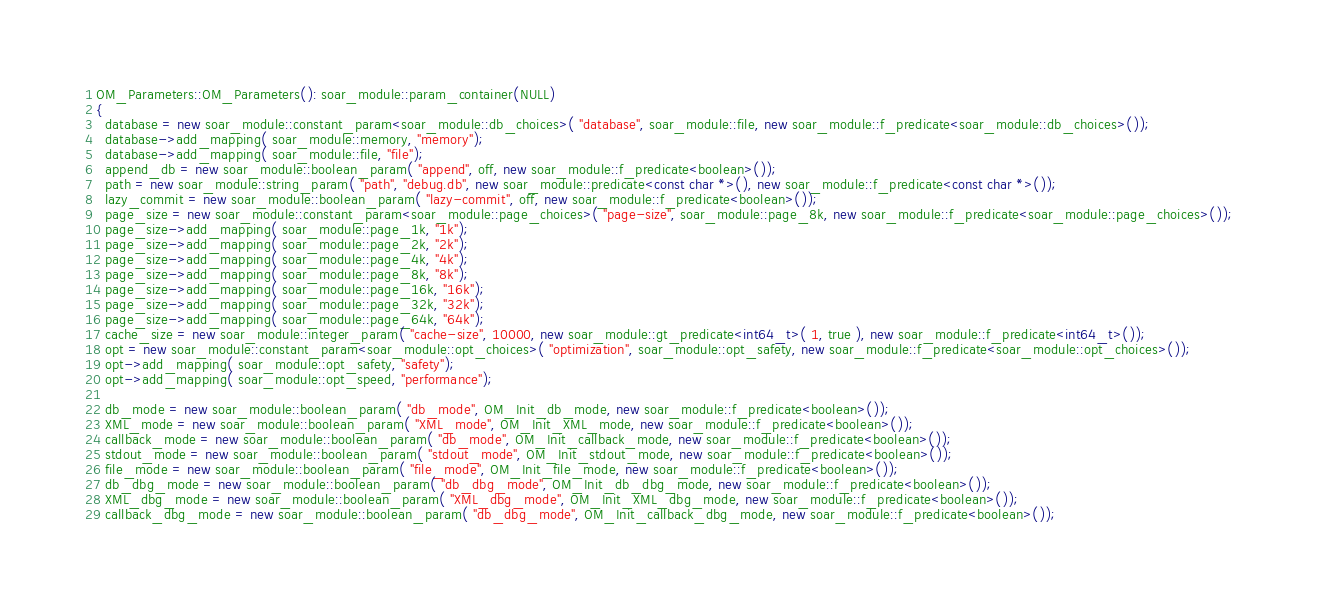Convert code to text. <code><loc_0><loc_0><loc_500><loc_500><_C++_>OM_Parameters::OM_Parameters(): soar_module::param_container(NULL)
{
  database = new soar_module::constant_param<soar_module::db_choices>( "database", soar_module::file, new soar_module::f_predicate<soar_module::db_choices>());
  database->add_mapping( soar_module::memory, "memory");
  database->add_mapping( soar_module::file, "file");
  append_db = new soar_module::boolean_param( "append", off, new soar_module::f_predicate<boolean>());
  path = new soar_module::string_param( "path", "debug.db", new soar_module::predicate<const char *>(), new soar_module::f_predicate<const char *>());
  lazy_commit = new soar_module::boolean_param( "lazy-commit", off, new soar_module::f_predicate<boolean>());
  page_size = new soar_module::constant_param<soar_module::page_choices>( "page-size", soar_module::page_8k, new soar_module::f_predicate<soar_module::page_choices>());
  page_size->add_mapping( soar_module::page_1k, "1k");
  page_size->add_mapping( soar_module::page_2k, "2k");
  page_size->add_mapping( soar_module::page_4k, "4k");
  page_size->add_mapping( soar_module::page_8k, "8k");
  page_size->add_mapping( soar_module::page_16k, "16k");
  page_size->add_mapping( soar_module::page_32k, "32k");
  page_size->add_mapping( soar_module::page_64k, "64k");
  cache_size = new soar_module::integer_param( "cache-size", 10000, new soar_module::gt_predicate<int64_t>( 1, true ), new soar_module::f_predicate<int64_t>());
  opt = new soar_module::constant_param<soar_module::opt_choices>( "optimization", soar_module::opt_safety, new soar_module::f_predicate<soar_module::opt_choices>());
  opt->add_mapping( soar_module::opt_safety, "safety");
  opt->add_mapping( soar_module::opt_speed, "performance");

  db_mode = new soar_module::boolean_param( "db_mode", OM_Init_db_mode, new soar_module::f_predicate<boolean>());
  XML_mode = new soar_module::boolean_param( "XML_mode", OM_Init_XML_mode, new soar_module::f_predicate<boolean>());
  callback_mode = new soar_module::boolean_param( "db_mode", OM_Init_callback_mode, new soar_module::f_predicate<boolean>());
  stdout_mode = new soar_module::boolean_param( "stdout_mode", OM_Init_stdout_mode, new soar_module::f_predicate<boolean>());
  file_mode = new soar_module::boolean_param( "file_mode", OM_Init_file_mode, new soar_module::f_predicate<boolean>());
  db_dbg_mode = new soar_module::boolean_param( "db_dbg_mode", OM_Init_db_dbg_mode, new soar_module::f_predicate<boolean>());
  XML_dbg_mode = new soar_module::boolean_param( "XML_dbg_mode", OM_Init_XML_dbg_mode, new soar_module::f_predicate<boolean>());
  callback_dbg_mode = new soar_module::boolean_param( "db_dbg_mode", OM_Init_callback_dbg_mode, new soar_module::f_predicate<boolean>());</code> 